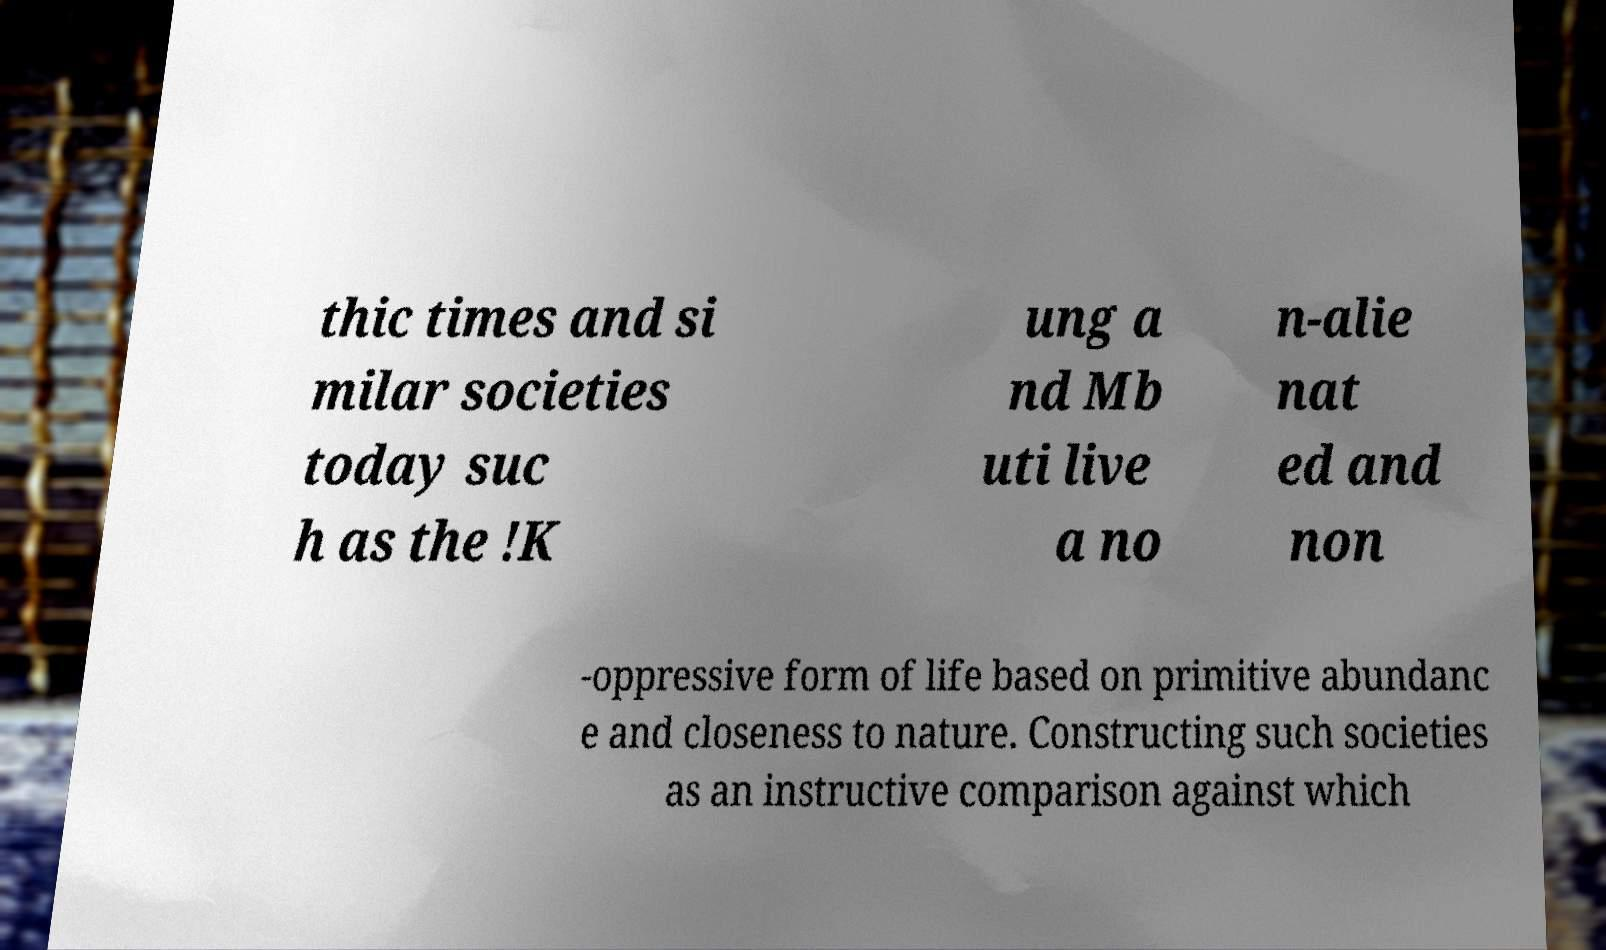Could you extract and type out the text from this image? thic times and si milar societies today suc h as the !K ung a nd Mb uti live a no n-alie nat ed and non -oppressive form of life based on primitive abundanc e and closeness to nature. Constructing such societies as an instructive comparison against which 